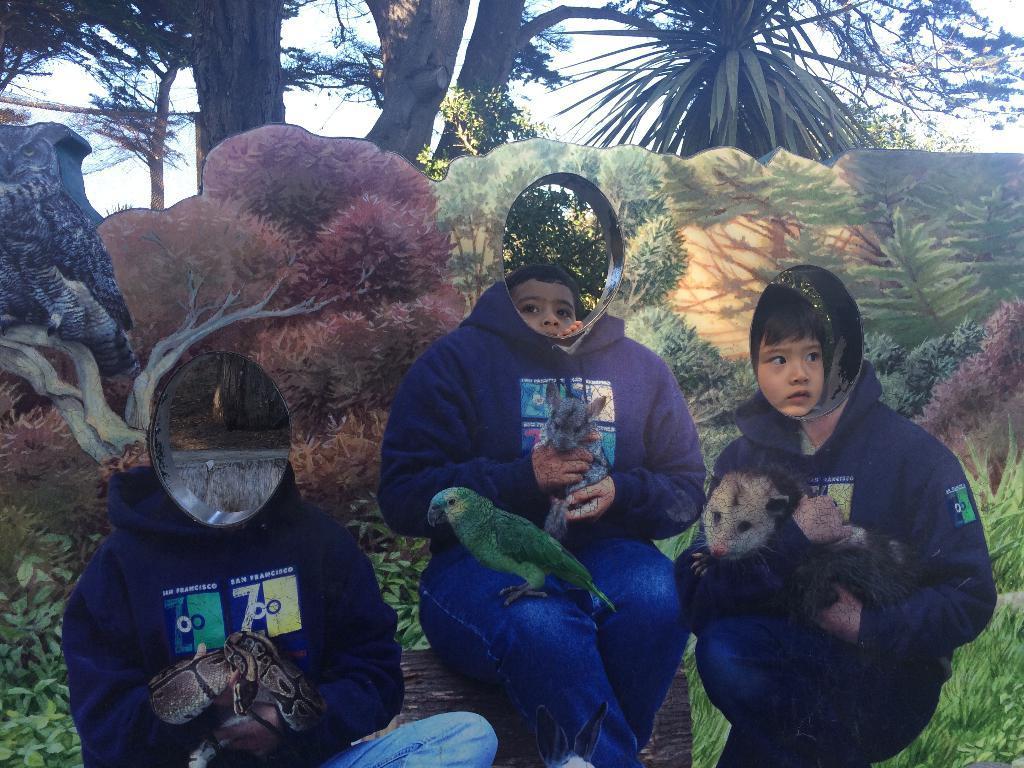Can you describe this image briefly? In this image, we can see a cardboard cutout contains depiction of persons, animals,trees, plants and parrot. There are kids faces in the middle of the image. There are trees at the top of the image. 